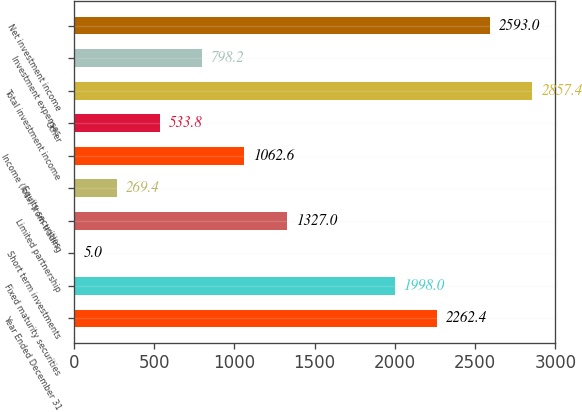Convert chart to OTSL. <chart><loc_0><loc_0><loc_500><loc_500><bar_chart><fcel>Year Ended December 31<fcel>Fixed maturity securities<fcel>Short term investments<fcel>Limited partnership<fcel>Equity securities<fcel>Income (loss) from trading<fcel>Other<fcel>Total investment income<fcel>Investment expenses<fcel>Net investment income<nl><fcel>2262.4<fcel>1998<fcel>5<fcel>1327<fcel>269.4<fcel>1062.6<fcel>533.8<fcel>2857.4<fcel>798.2<fcel>2593<nl></chart> 